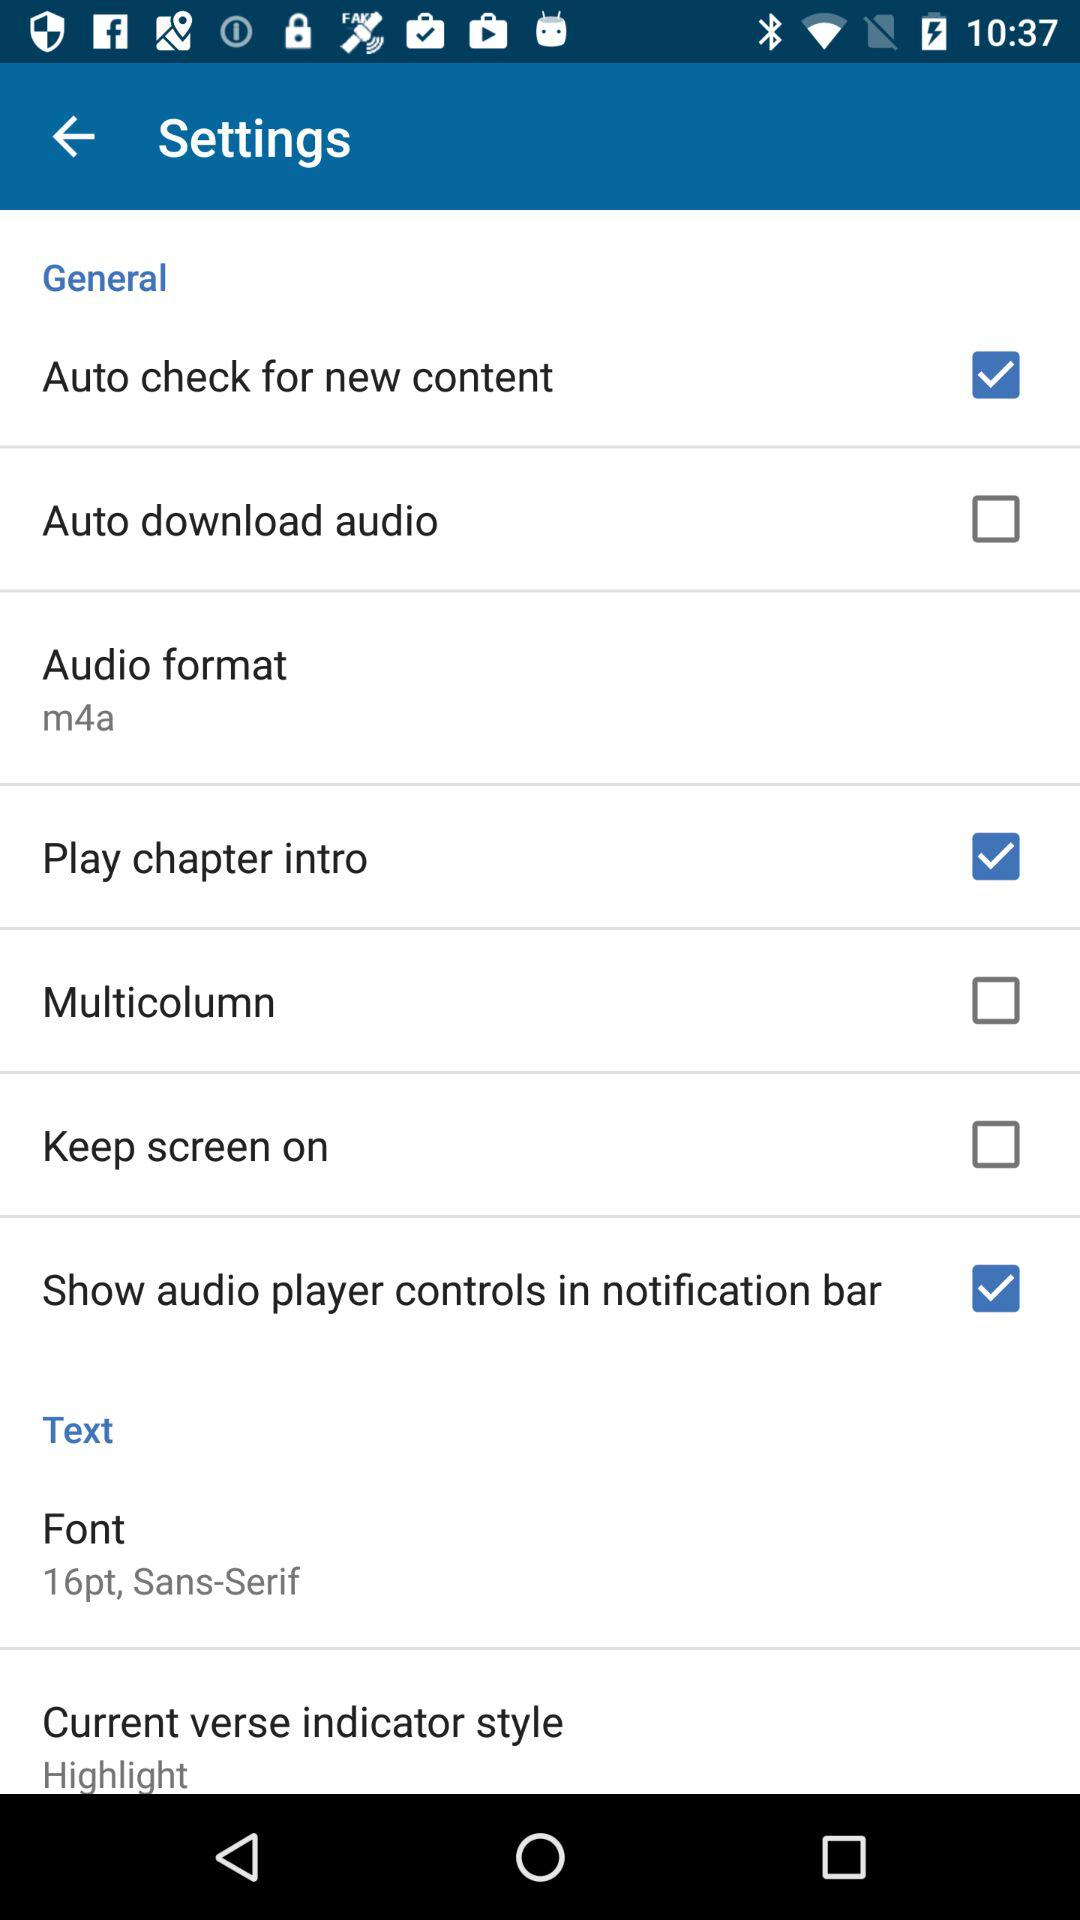What is the selected font size? The selected font size is 16 points. 